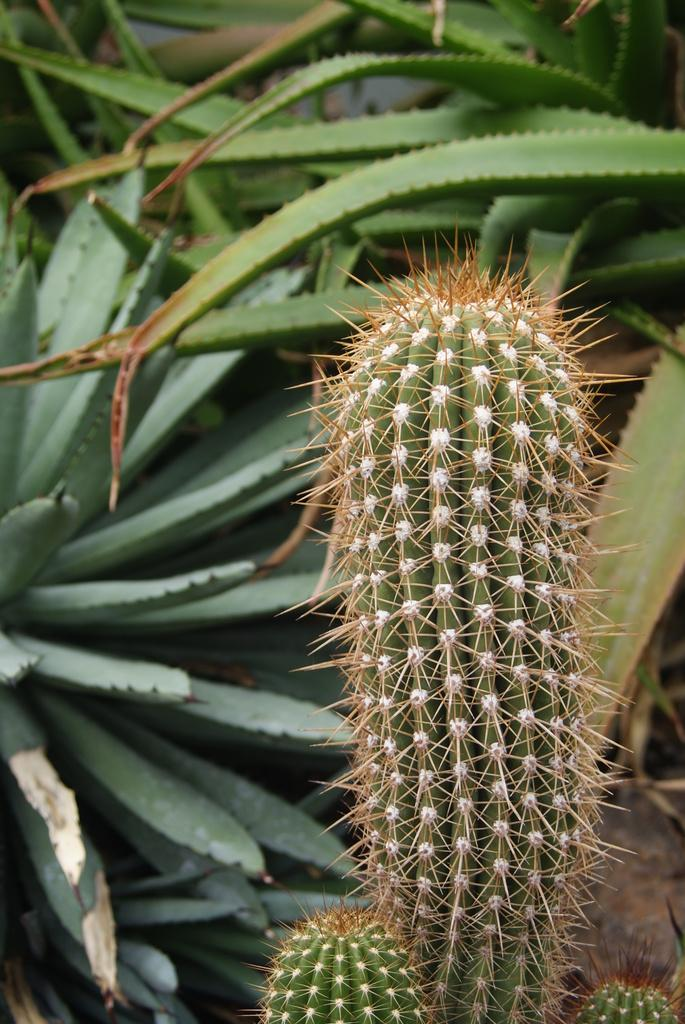What type of plant is in the image? There is a cactus plant in the image. Can you describe the background of the image? There are other plants in the background of the image. What mark does the cactus plant have on its side in the image? There is no mark visible on the cactus plant in the image. How often does the cactus plant need to be watered, according to the image? The image does not provide information about the watering schedule for the cactus plant. 